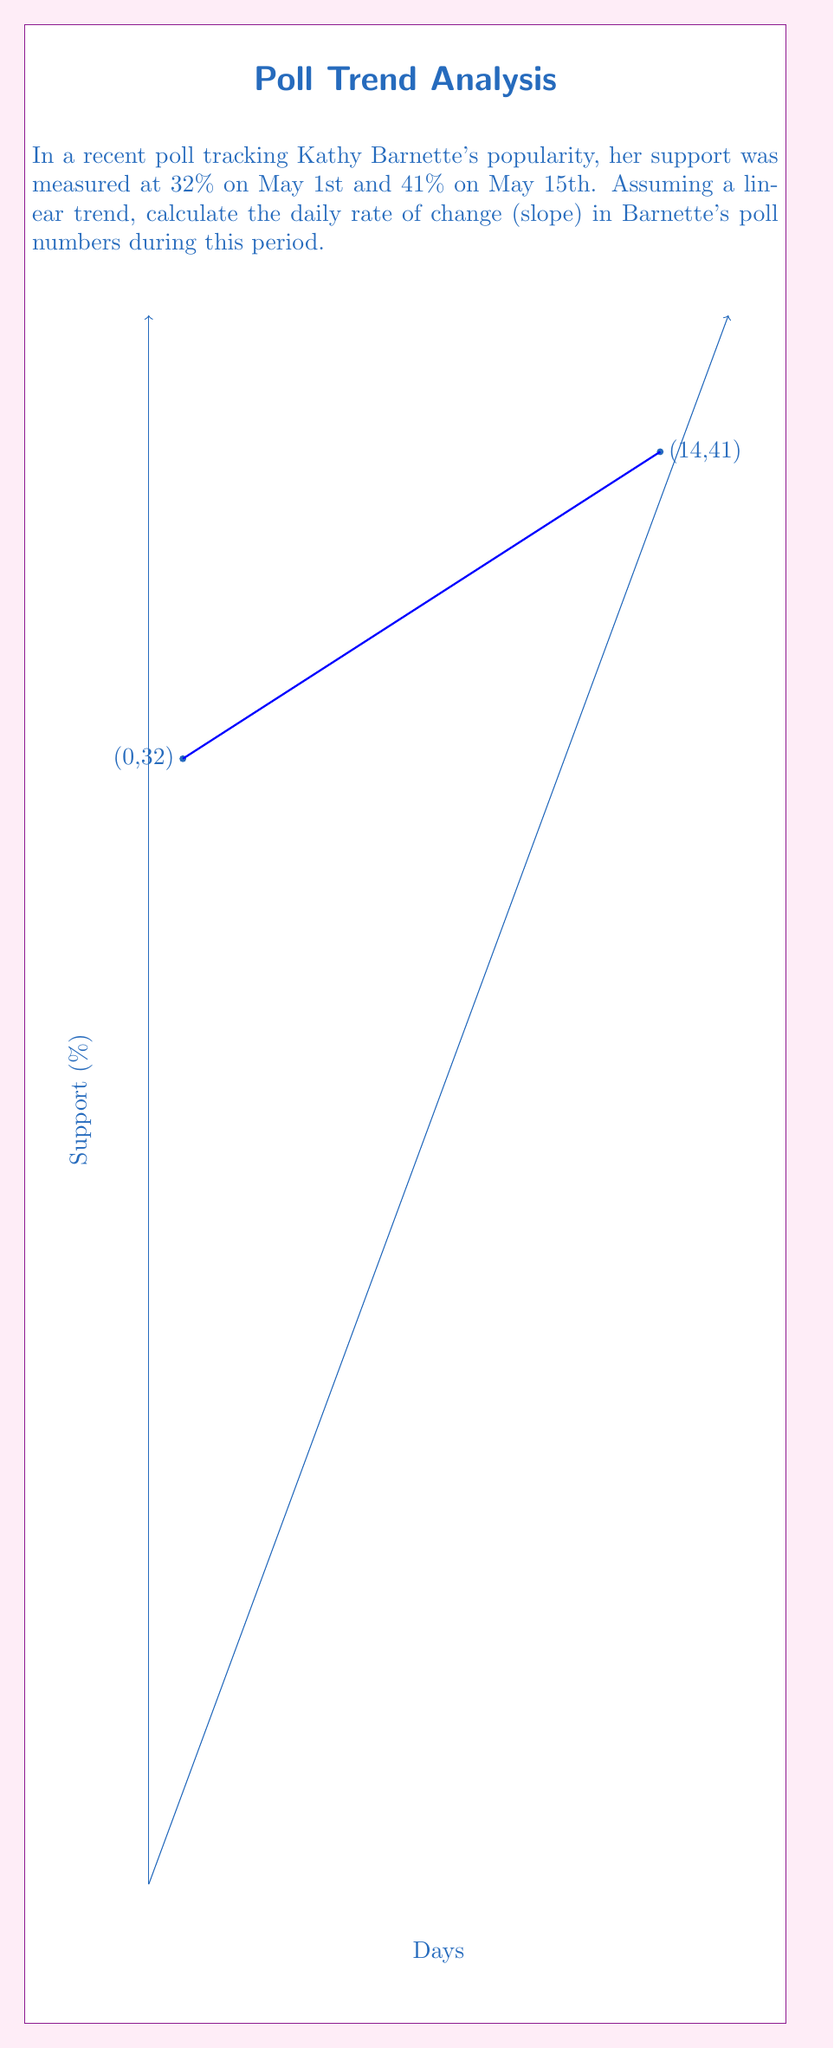What is the answer to this math problem? To find the slope of the line representing Kathy Barnette's poll numbers over time, we'll use the slope formula:

$$ m = \frac{y_2 - y_1}{x_2 - x_1} $$

Where:
$(x_1, y_1)$ is the first point: May 1st (day 0) with 32% support
$(x_2, y_2)$ is the second point: May 15th (day 14) with 41% support

Plugging in the values:

$$ m = \frac{41 - 32}{14 - 0} = \frac{9}{14} $$

Simplifying:

$$ m = \frac{9}{14} = 0.6428571429 $$

This represents the daily rate of change in Barnette's poll numbers. To express it as a percentage per day, we multiply by 100:

$$ 0.6428571429 * 100 = 64.28571429\% \text{ per day} $$

Rounding to two decimal places for practical use:

$$ 0.64\% \text{ per day} $$
Answer: $0.64\%$ per day 